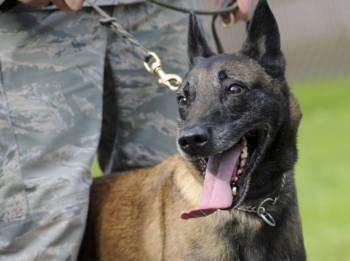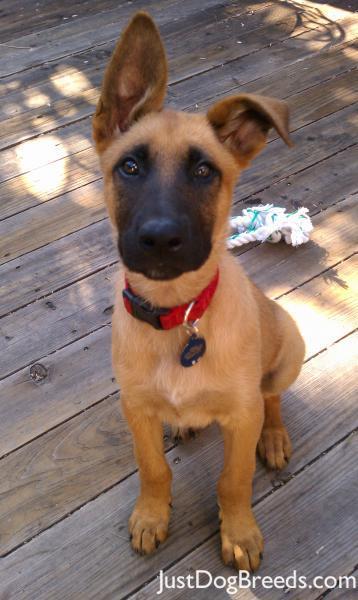The first image is the image on the left, the second image is the image on the right. Evaluate the accuracy of this statement regarding the images: "The dog in the image on the right is near an area of green grass.". Is it true? Answer yes or no. No. The first image is the image on the left, the second image is the image on the right. Assess this claim about the two images: "The left image contains one dog with its tongue hanging out.". Correct or not? Answer yes or no. Yes. 